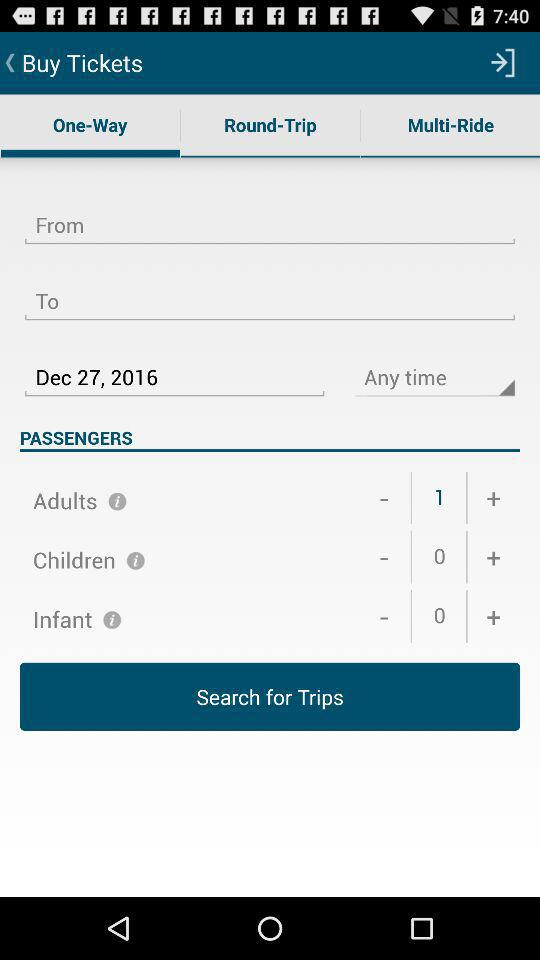Which tab has been selected? The tab "One-Way" has been selected. 